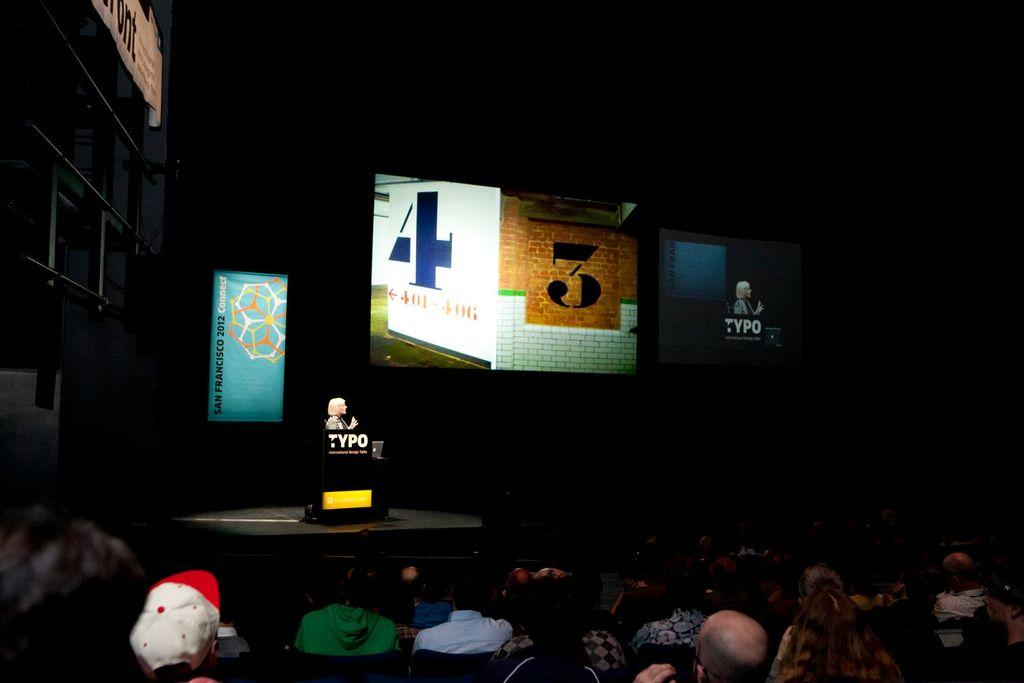How many people are in the image? There is a group of people in the image, but the exact number cannot be determined from the provided facts. What is the person standing on the floor doing? The person standing on the floor is not described in the provided facts, so we cannot determine their actions. What is the purpose of the podium in the image? The purpose of the podium in the image is not mentioned in the provided facts, so we cannot determine its use. What is written on the banners in the image? The content of the banners is not mentioned in the provided facts, so we cannot determine what is written on them. What is displayed on the screens in the image? The content displayed on the screens is not mentioned in the provided facts, so we cannot determine what is shown on them. What is the lighting condition in the image? The background of the image is dark, which suggests that the lighting is dim or low. Can you hear the whistle in the image? There is no mention of a whistle in the provided facts, so we cannot determine if it is present or audible in the image. 